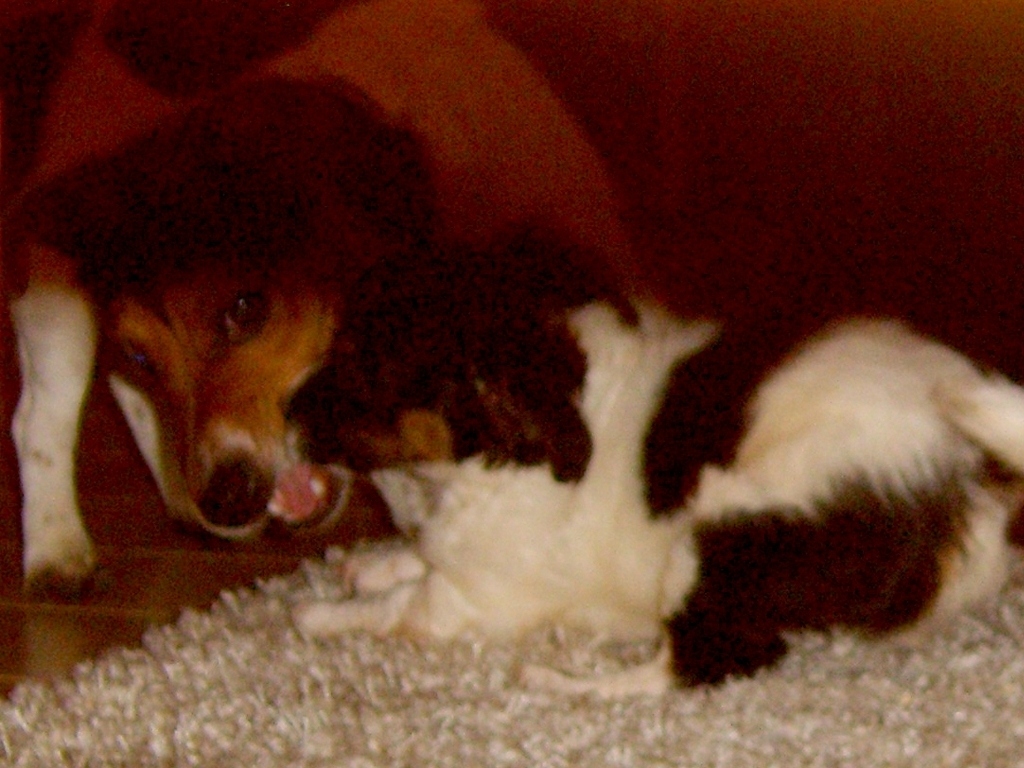What are the animals doing in this image? The animals, a dog and a cat, appear to be engaged in a playful or affectionate interaction. The dog seems to be gently biting or nibbling on the cat, which is a common playful behavior seen in pets who are comfortable with each other. 